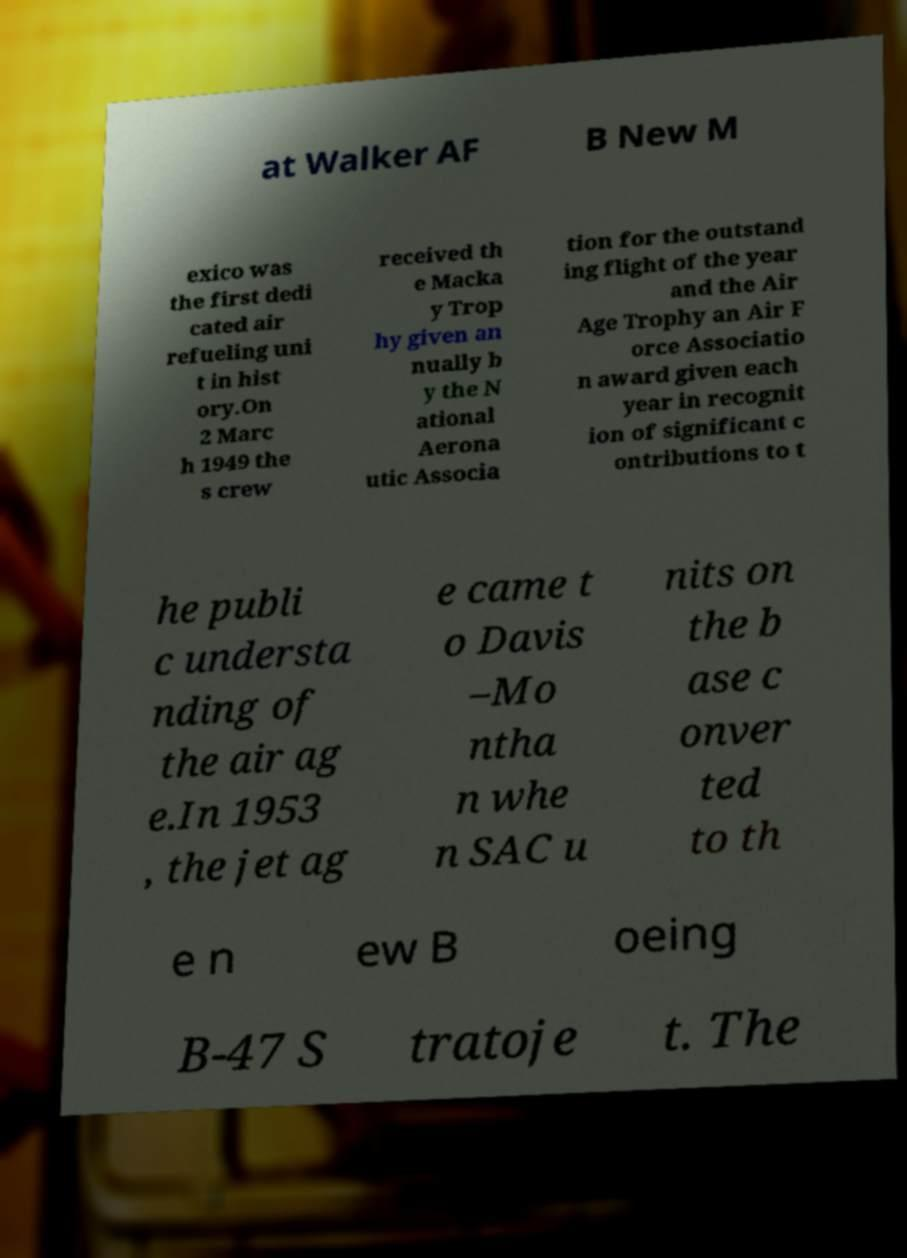I need the written content from this picture converted into text. Can you do that? at Walker AF B New M exico was the first dedi cated air refueling uni t in hist ory.On 2 Marc h 1949 the s crew received th e Macka y Trop hy given an nually b y the N ational Aerona utic Associa tion for the outstand ing flight of the year and the Air Age Trophy an Air F orce Associatio n award given each year in recognit ion of significant c ontributions to t he publi c understa nding of the air ag e.In 1953 , the jet ag e came t o Davis –Mo ntha n whe n SAC u nits on the b ase c onver ted to th e n ew B oeing B-47 S tratoje t. The 